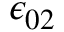<formula> <loc_0><loc_0><loc_500><loc_500>\epsilon _ { 0 2 }</formula> 